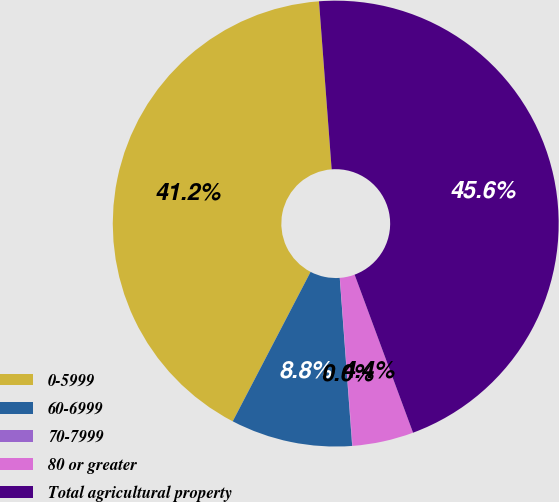Convert chart. <chart><loc_0><loc_0><loc_500><loc_500><pie_chart><fcel>0-5999<fcel>60-6999<fcel>70-7999<fcel>80 or greater<fcel>Total agricultural property<nl><fcel>41.16%<fcel>8.82%<fcel>0.03%<fcel>4.43%<fcel>45.56%<nl></chart> 